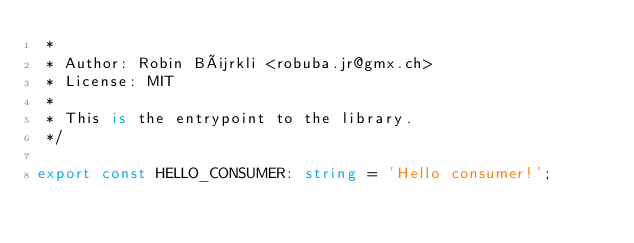<code> <loc_0><loc_0><loc_500><loc_500><_TypeScript_> *
 * Author: Robin Bürkli <robuba.jr@gmx.ch>
 * License: MIT
 *
 * This is the entrypoint to the library.
 */

export const HELLO_CONSUMER: string = 'Hello consumer!';
</code> 